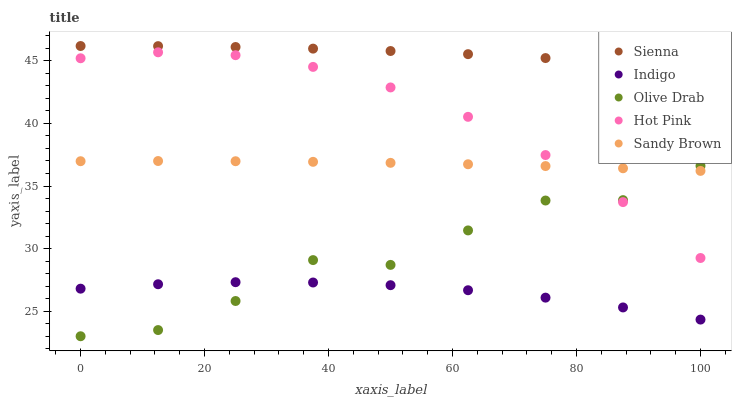Does Indigo have the minimum area under the curve?
Answer yes or no. Yes. Does Sienna have the maximum area under the curve?
Answer yes or no. Yes. Does Sandy Brown have the minimum area under the curve?
Answer yes or no. No. Does Sandy Brown have the maximum area under the curve?
Answer yes or no. No. Is Sandy Brown the smoothest?
Answer yes or no. Yes. Is Olive Drab the roughest?
Answer yes or no. Yes. Is Hot Pink the smoothest?
Answer yes or no. No. Is Hot Pink the roughest?
Answer yes or no. No. Does Olive Drab have the lowest value?
Answer yes or no. Yes. Does Sandy Brown have the lowest value?
Answer yes or no. No. Does Sienna have the highest value?
Answer yes or no. Yes. Does Sandy Brown have the highest value?
Answer yes or no. No. Is Sandy Brown less than Sienna?
Answer yes or no. Yes. Is Sandy Brown greater than Indigo?
Answer yes or no. Yes. Does Sandy Brown intersect Hot Pink?
Answer yes or no. Yes. Is Sandy Brown less than Hot Pink?
Answer yes or no. No. Is Sandy Brown greater than Hot Pink?
Answer yes or no. No. Does Sandy Brown intersect Sienna?
Answer yes or no. No. 